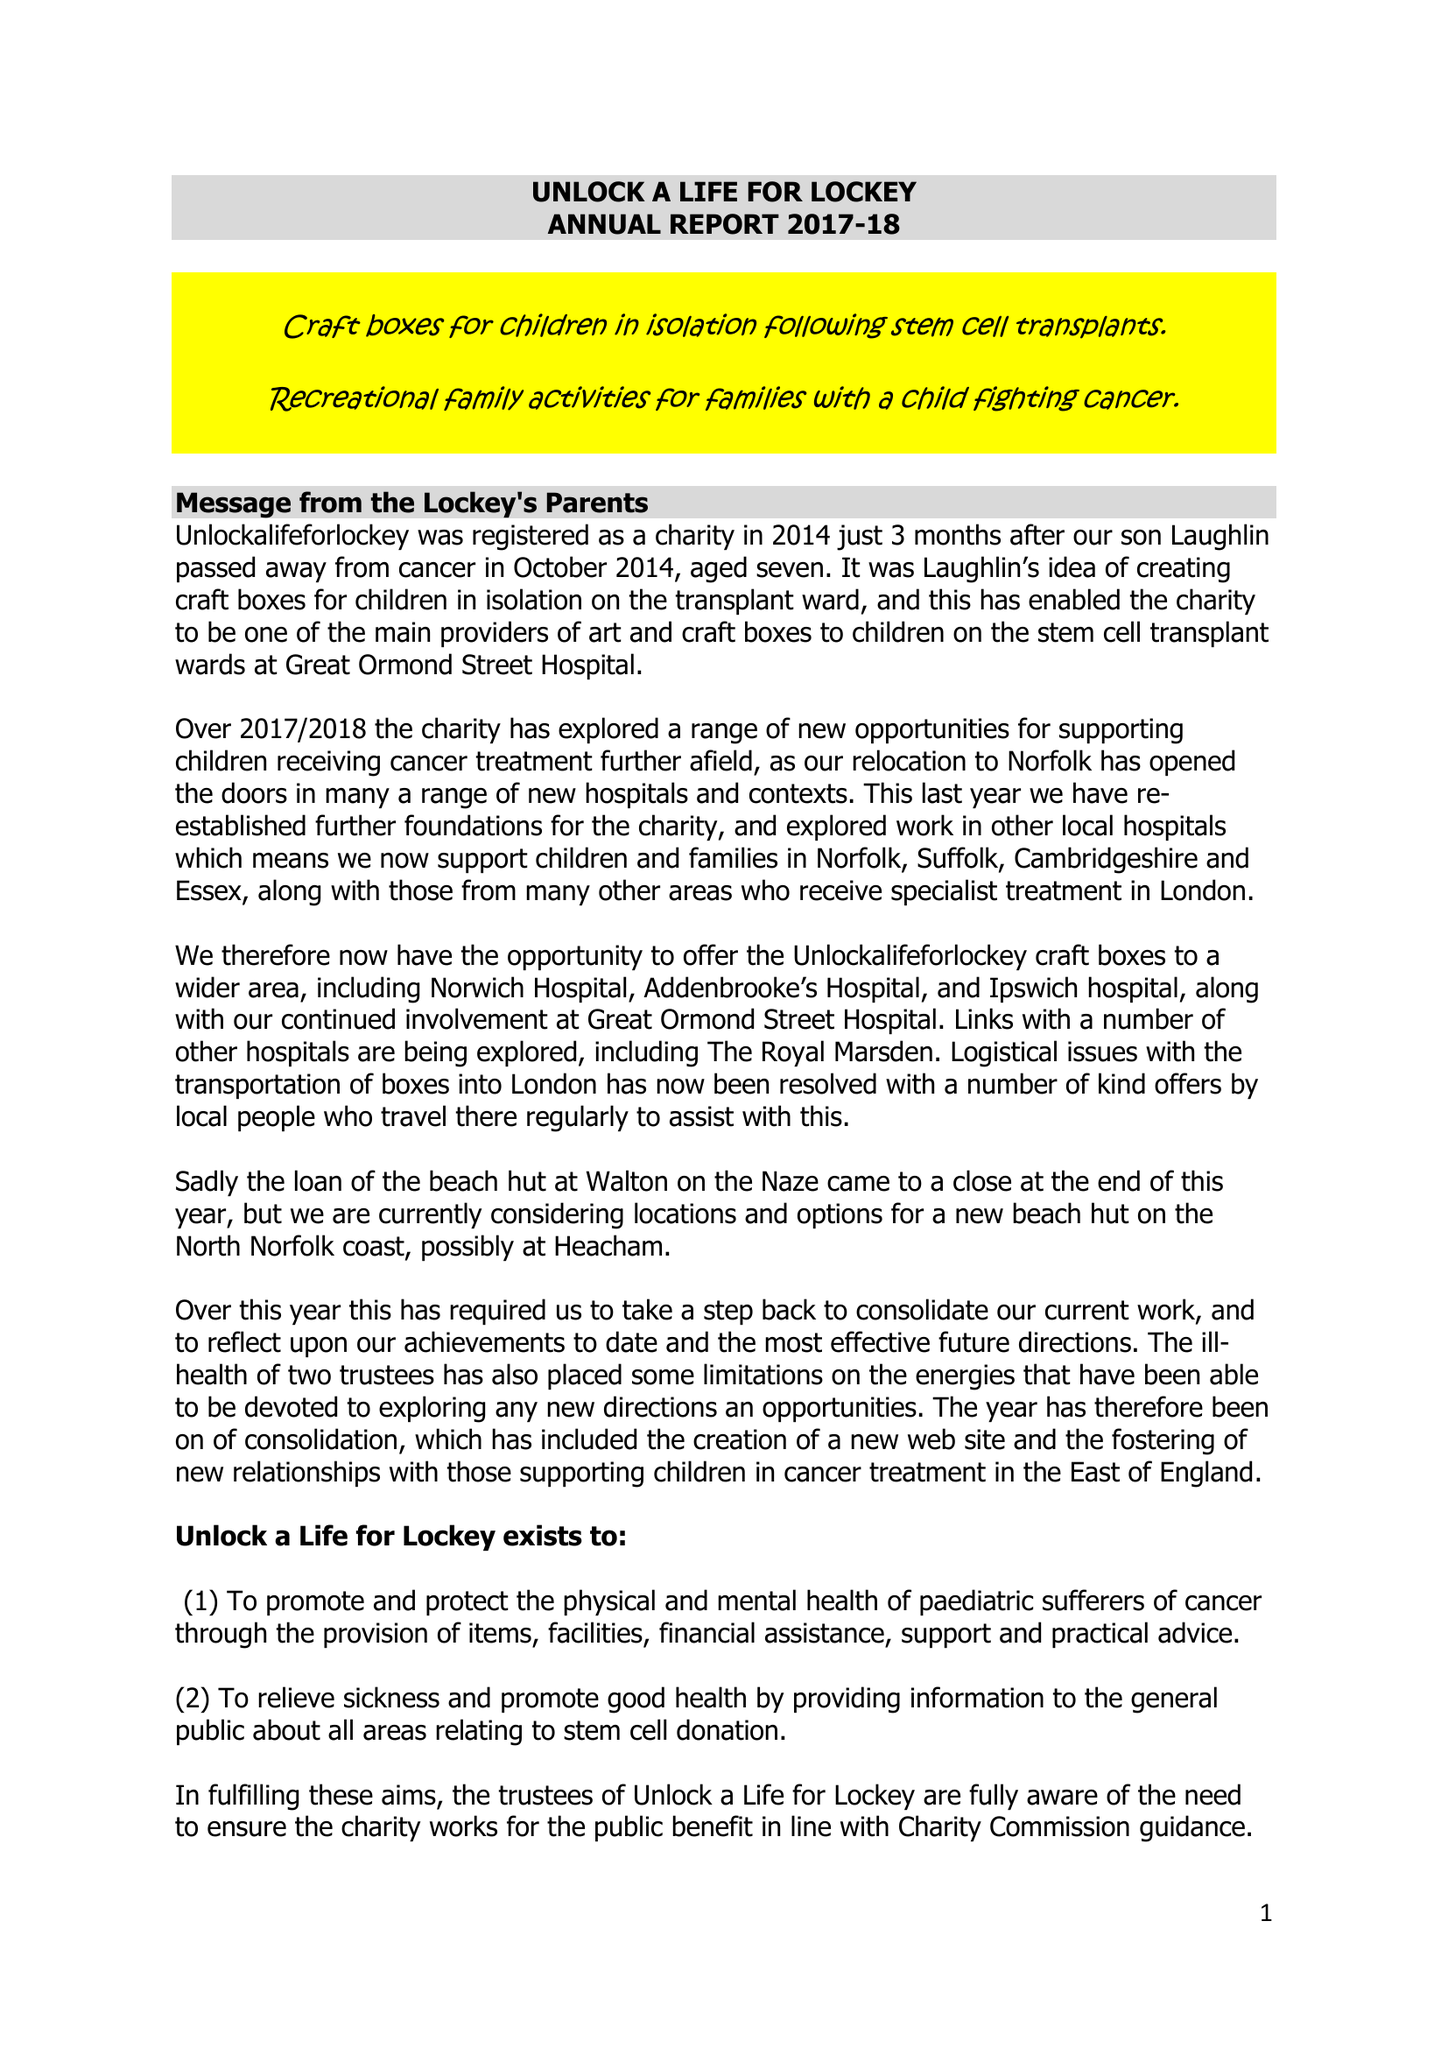What is the value for the report_date?
Answer the question using a single word or phrase. 2018-03-31 